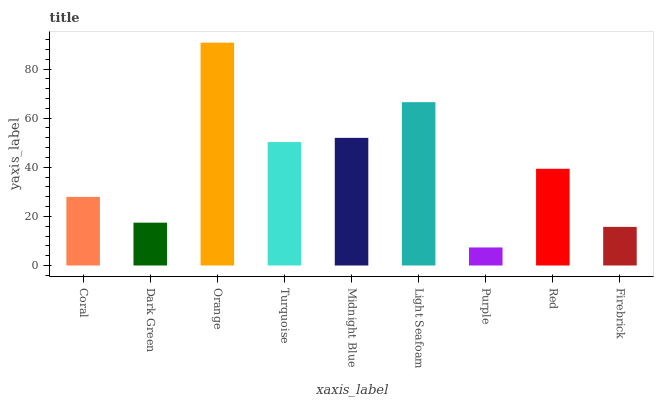Is Purple the minimum?
Answer yes or no. Yes. Is Orange the maximum?
Answer yes or no. Yes. Is Dark Green the minimum?
Answer yes or no. No. Is Dark Green the maximum?
Answer yes or no. No. Is Coral greater than Dark Green?
Answer yes or no. Yes. Is Dark Green less than Coral?
Answer yes or no. Yes. Is Dark Green greater than Coral?
Answer yes or no. No. Is Coral less than Dark Green?
Answer yes or no. No. Is Red the high median?
Answer yes or no. Yes. Is Red the low median?
Answer yes or no. Yes. Is Dark Green the high median?
Answer yes or no. No. Is Firebrick the low median?
Answer yes or no. No. 